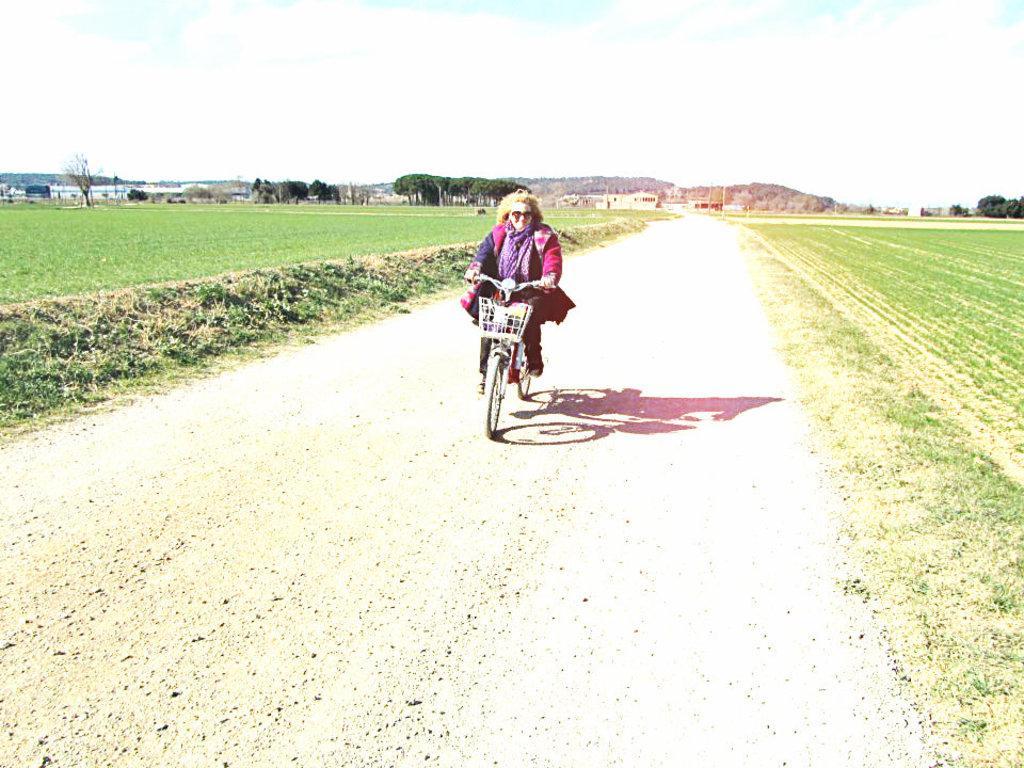How would you summarize this image in a sentence or two? In this image I can see the person riding the bicycle. In the background I can see the grass and few trees in green color and I can also see few buildings and the sky is in white and blue color. 